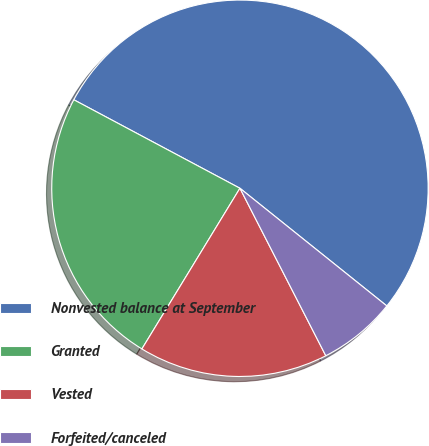Convert chart to OTSL. <chart><loc_0><loc_0><loc_500><loc_500><pie_chart><fcel>Nonvested balance at September<fcel>Granted<fcel>Vested<fcel>Forfeited/canceled<nl><fcel>52.96%<fcel>24.07%<fcel>16.26%<fcel>6.71%<nl></chart> 